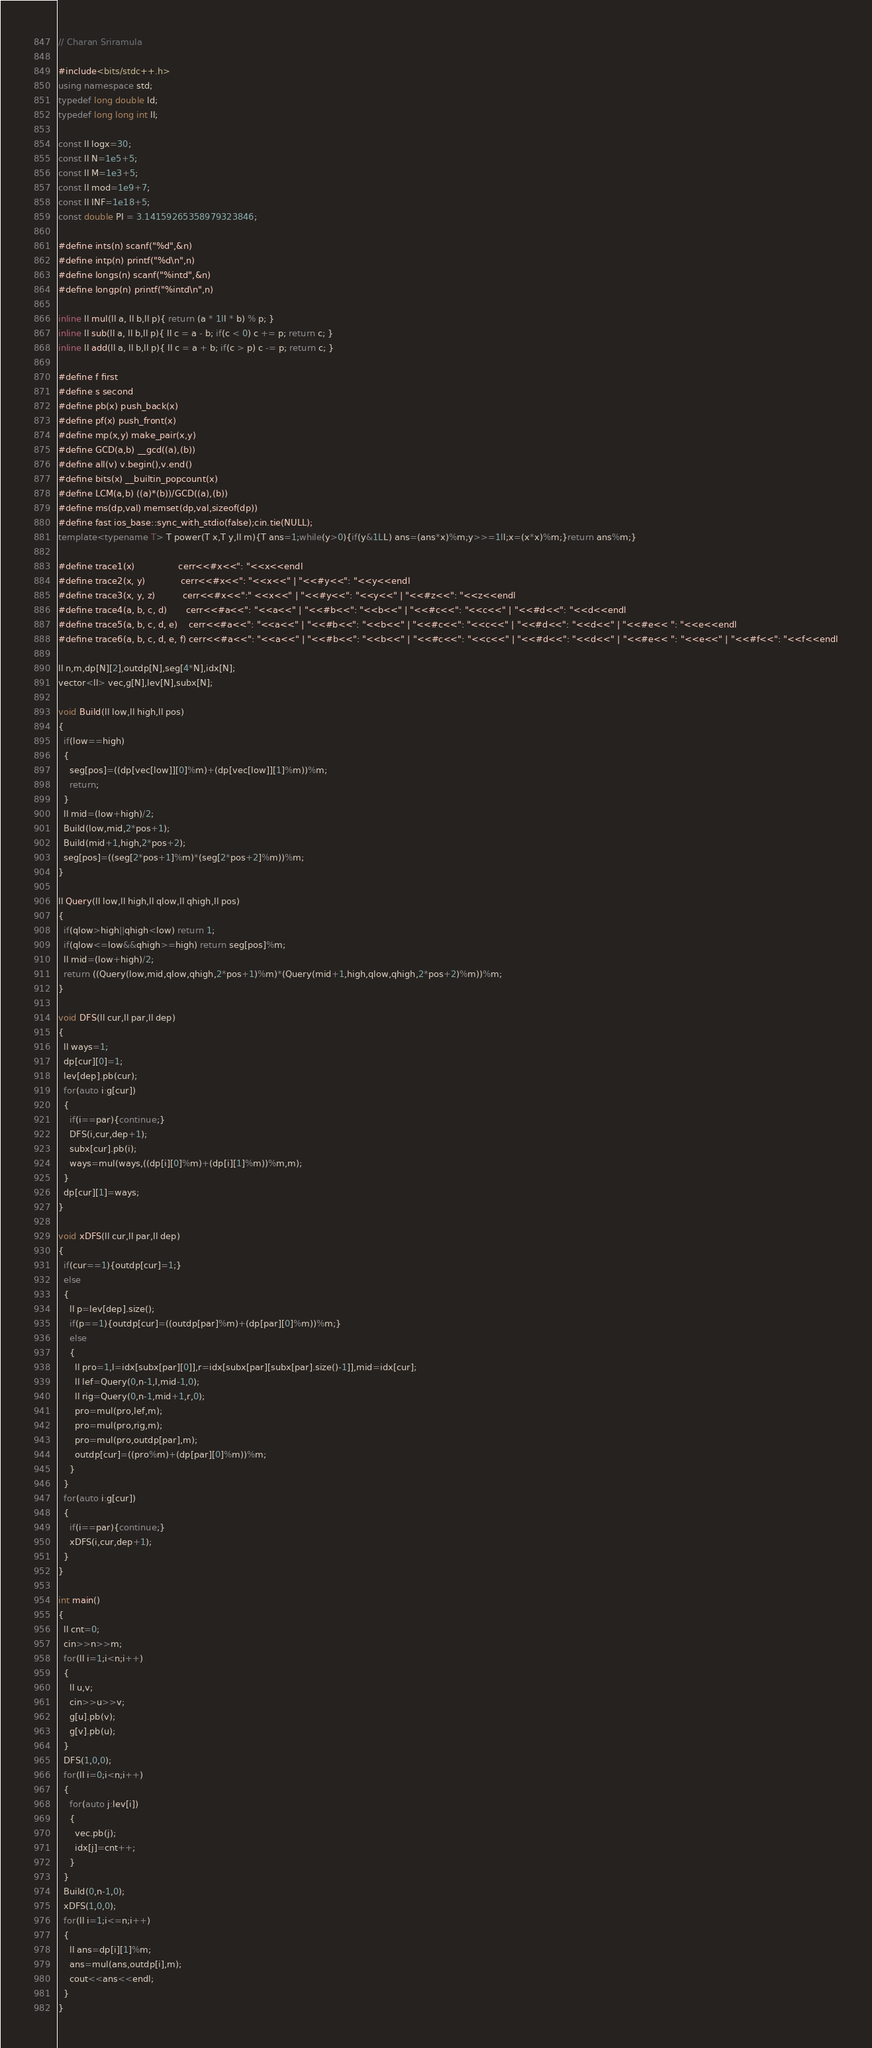<code> <loc_0><loc_0><loc_500><loc_500><_C++_>// Charan Sriramula

#include<bits/stdc++.h>
using namespace std;
typedef long double ld;
typedef long long int ll;

const ll logx=30;
const ll N=1e5+5;
const ll M=1e3+5;
const ll mod=1e9+7;
const ll INF=1e18+5;
const double PI = 3.14159265358979323846;

#define ints(n) scanf("%d",&n)
#define intp(n) printf("%d\n",n)
#define longs(n) scanf("%intd",&n)
#define longp(n) printf("%intd\n",n)

inline ll mul(ll a, ll b,ll p){ return (a * 1ll * b) % p; }
inline ll sub(ll a, ll b,ll p){ ll c = a - b; if(c < 0) c += p; return c; }
inline ll add(ll a, ll b,ll p){ ll c = a + b; if(c > p) c -= p; return c; }

#define f first
#define s second
#define pb(x) push_back(x)
#define pf(x) push_front(x)
#define mp(x,y) make_pair(x,y)
#define GCD(a,b) __gcd((a),(b))
#define all(v) v.begin(),v.end()
#define bits(x) __builtin_popcount(x)
#define LCM(a,b) ((a)*(b))/GCD((a),(b))
#define ms(dp,val) memset(dp,val,sizeof(dp))
#define fast ios_base::sync_with_stdio(false);cin.tie(NULL);
template<typename T> T power(T x,T y,ll m){T ans=1;while(y>0){if(y&1LL) ans=(ans*x)%m;y>>=1ll;x=(x*x)%m;}return ans%m;}

#define trace1(x)                cerr<<#x<<": "<<x<<endl
#define trace2(x, y)             cerr<<#x<<": "<<x<<" | "<<#y<<": "<<y<<endl
#define trace3(x, y, z)          cerr<<#x<<":" <<x<<" | "<<#y<<": "<<y<<" | "<<#z<<": "<<z<<endl
#define trace4(a, b, c, d)       cerr<<#a<<": "<<a<<" | "<<#b<<": "<<b<<" | "<<#c<<": "<<c<<" | "<<#d<<": "<<d<<endl
#define trace5(a, b, c, d, e)    cerr<<#a<<": "<<a<<" | "<<#b<<": "<<b<<" | "<<#c<<": "<<c<<" | "<<#d<<": "<<d<<" | "<<#e<< ": "<<e<<endl
#define trace6(a, b, c, d, e, f) cerr<<#a<<": "<<a<<" | "<<#b<<": "<<b<<" | "<<#c<<": "<<c<<" | "<<#d<<": "<<d<<" | "<<#e<< ": "<<e<<" | "<<#f<<": "<<f<<endl

ll n,m,dp[N][2],outdp[N],seg[4*N],idx[N];
vector<ll> vec,g[N],lev[N],subx[N];

void Build(ll low,ll high,ll pos)
{
  if(low==high)
  {
    seg[pos]=((dp[vec[low]][0]%m)+(dp[vec[low]][1]%m))%m;
    return;
  }
  ll mid=(low+high)/2;
  Build(low,mid,2*pos+1);
  Build(mid+1,high,2*pos+2);
  seg[pos]=((seg[2*pos+1]%m)*(seg[2*pos+2]%m))%m;
}

ll Query(ll low,ll high,ll qlow,ll qhigh,ll pos)
{
  if(qlow>high||qhigh<low) return 1;
  if(qlow<=low&&qhigh>=high) return seg[pos]%m;
  ll mid=(low+high)/2;
  return ((Query(low,mid,qlow,qhigh,2*pos+1)%m)*(Query(mid+1,high,qlow,qhigh,2*pos+2)%m))%m;
}

void DFS(ll cur,ll par,ll dep)
{
  ll ways=1;
  dp[cur][0]=1;
  lev[dep].pb(cur);
  for(auto i:g[cur])
  {
    if(i==par){continue;}
    DFS(i,cur,dep+1);
    subx[cur].pb(i);
    ways=mul(ways,((dp[i][0]%m)+(dp[i][1]%m))%m,m);
  }
  dp[cur][1]=ways;
}

void xDFS(ll cur,ll par,ll dep)
{
  if(cur==1){outdp[cur]=1;}
  else
  {
    ll p=lev[dep].size();
    if(p==1){outdp[cur]=((outdp[par]%m)+(dp[par][0]%m))%m;}
    else
    {
      ll pro=1,l=idx[subx[par][0]],r=idx[subx[par][subx[par].size()-1]],mid=idx[cur];
      ll lef=Query(0,n-1,l,mid-1,0);
      ll rig=Query(0,n-1,mid+1,r,0);
      pro=mul(pro,lef,m);
      pro=mul(pro,rig,m);
      pro=mul(pro,outdp[par],m);
      outdp[cur]=((pro%m)+(dp[par][0]%m))%m;
    }
  }
  for(auto i:g[cur])
  {
    if(i==par){continue;}
    xDFS(i,cur,dep+1);
  }
}

int main()
{
  ll cnt=0;
  cin>>n>>m;
  for(ll i=1;i<n;i++)
  {
    ll u,v;
    cin>>u>>v;
    g[u].pb(v);
    g[v].pb(u);
  }
  DFS(1,0,0);
  for(ll i=0;i<n;i++)
  {
    for(auto j:lev[i])
    {
      vec.pb(j);
      idx[j]=cnt++;
    }
  }
  Build(0,n-1,0);
  xDFS(1,0,0);
  for(ll i=1;i<=n;i++)
  {
    ll ans=dp[i][1]%m;
    ans=mul(ans,outdp[i],m);
    cout<<ans<<endl;
  }
}
</code> 